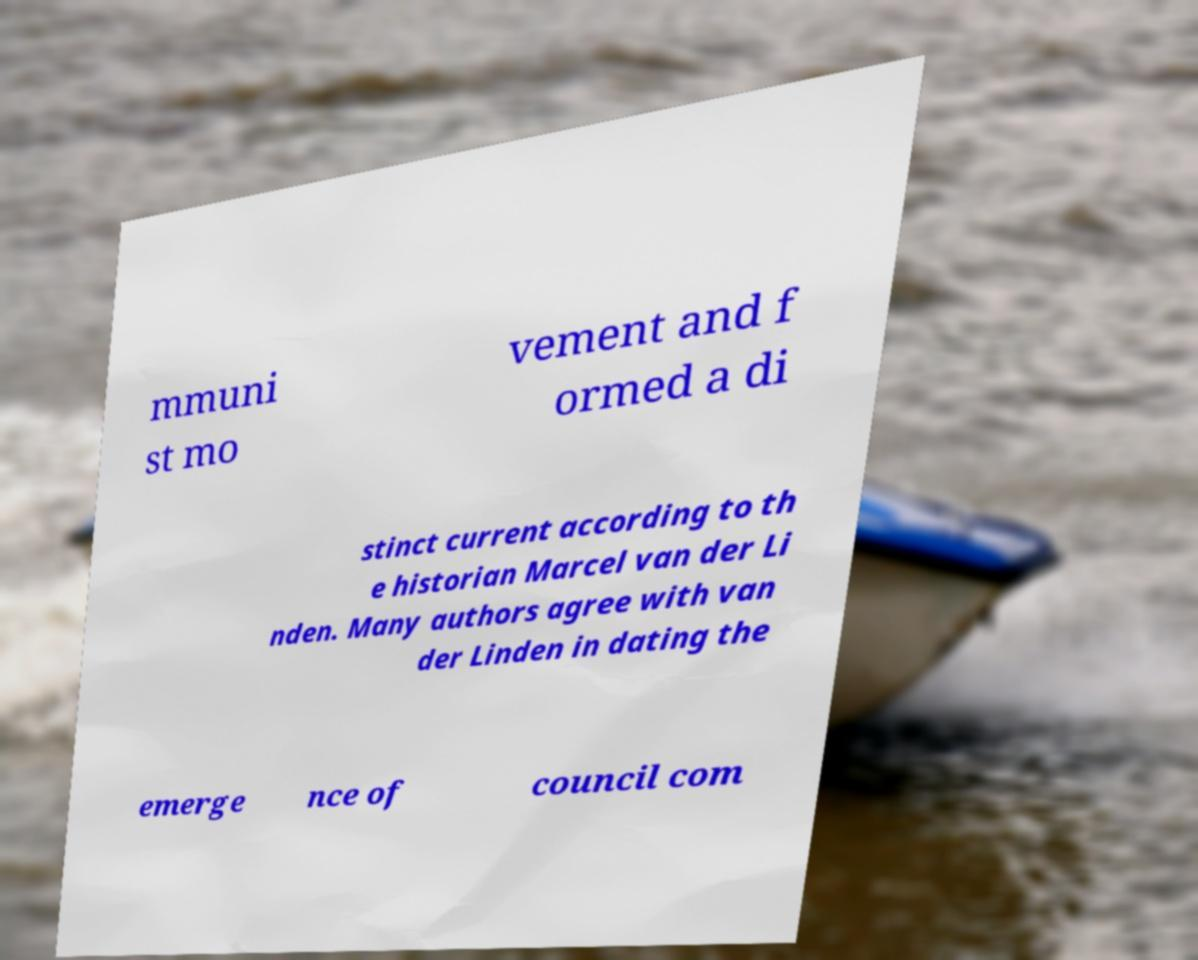Please identify and transcribe the text found in this image. mmuni st mo vement and f ormed a di stinct current according to th e historian Marcel van der Li nden. Many authors agree with van der Linden in dating the emerge nce of council com 